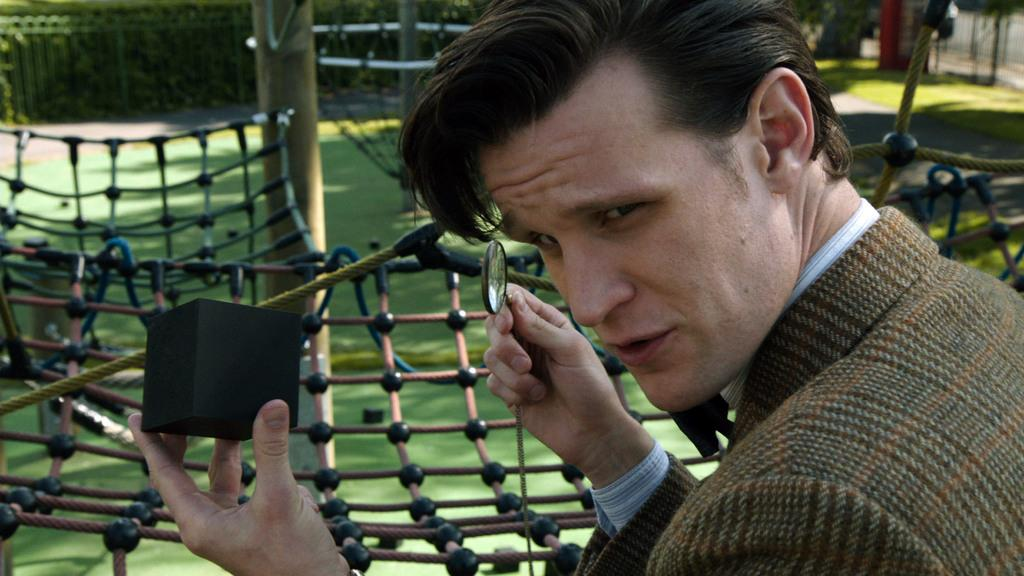What is the man in the image holding in his hand? The man is holding a magnifying glass and a black color box in his hand. What might the man be using the magnifying glass for? The man might be using the magnifying glass to examine something closely. What can be seen in the background of the image? In the background of the image, there is grass, nets, and fencing. What type of setting might this image be depicting? The presence of nets and grass suggests that this image might be depicting a sports or outdoor activity setting. What type of badge is the man wearing on his shirt in the image? There is no badge visible on the man's shirt in the image. What type of hospital equipment can be seen in the image? There is no hospital equipment present in the image; it features a man holding a magnifying glass and a black color box, with a background of grass, nets, and fencing. 